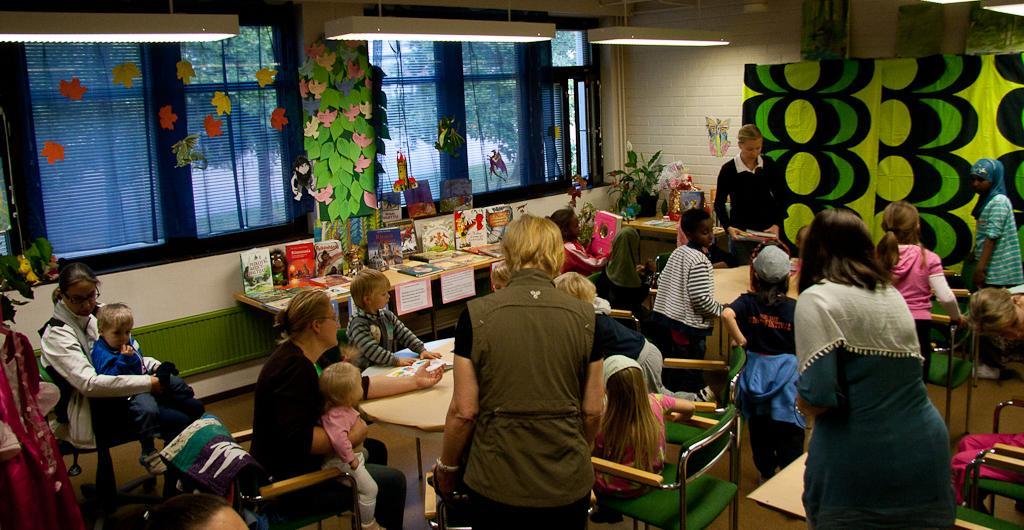Describe this image in one or two sentences. In this image I can see few people are sitting on the chairs and few are standing, on the left side there are books on the table, there are decorative items and windows. In the background there are trees, at the top there are lights. 